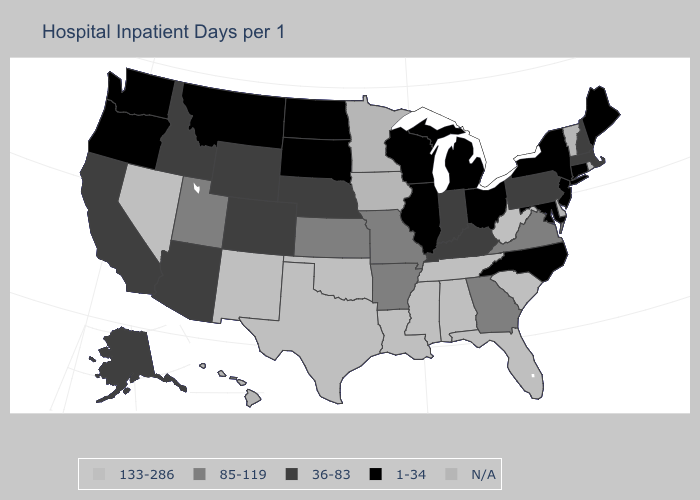Name the states that have a value in the range 36-83?
Write a very short answer. Alaska, Arizona, California, Colorado, Idaho, Indiana, Kentucky, Massachusetts, Nebraska, New Hampshire, Pennsylvania, Wyoming. Which states have the highest value in the USA?
Be succinct. Alabama, Florida, Louisiana, Mississippi, Nevada, New Mexico, Oklahoma, South Carolina, Tennessee, Texas, West Virginia. Does North Carolina have the lowest value in the South?
Answer briefly. Yes. Name the states that have a value in the range 133-286?
Quick response, please. Alabama, Florida, Louisiana, Mississippi, Nevada, New Mexico, Oklahoma, South Carolina, Tennessee, Texas, West Virginia. What is the value of Oklahoma?
Write a very short answer. 133-286. What is the value of Kansas?
Keep it brief. 85-119. What is the value of New York?
Quick response, please. 1-34. Does Alaska have the highest value in the USA?
Concise answer only. No. What is the value of Alaska?
Concise answer only. 36-83. Does New York have the lowest value in the Northeast?
Quick response, please. Yes. Does the first symbol in the legend represent the smallest category?
Short answer required. No. What is the value of North Dakota?
Keep it brief. 1-34. What is the value of Utah?
Give a very brief answer. 85-119. Which states hav the highest value in the West?
Short answer required. Nevada, New Mexico. 